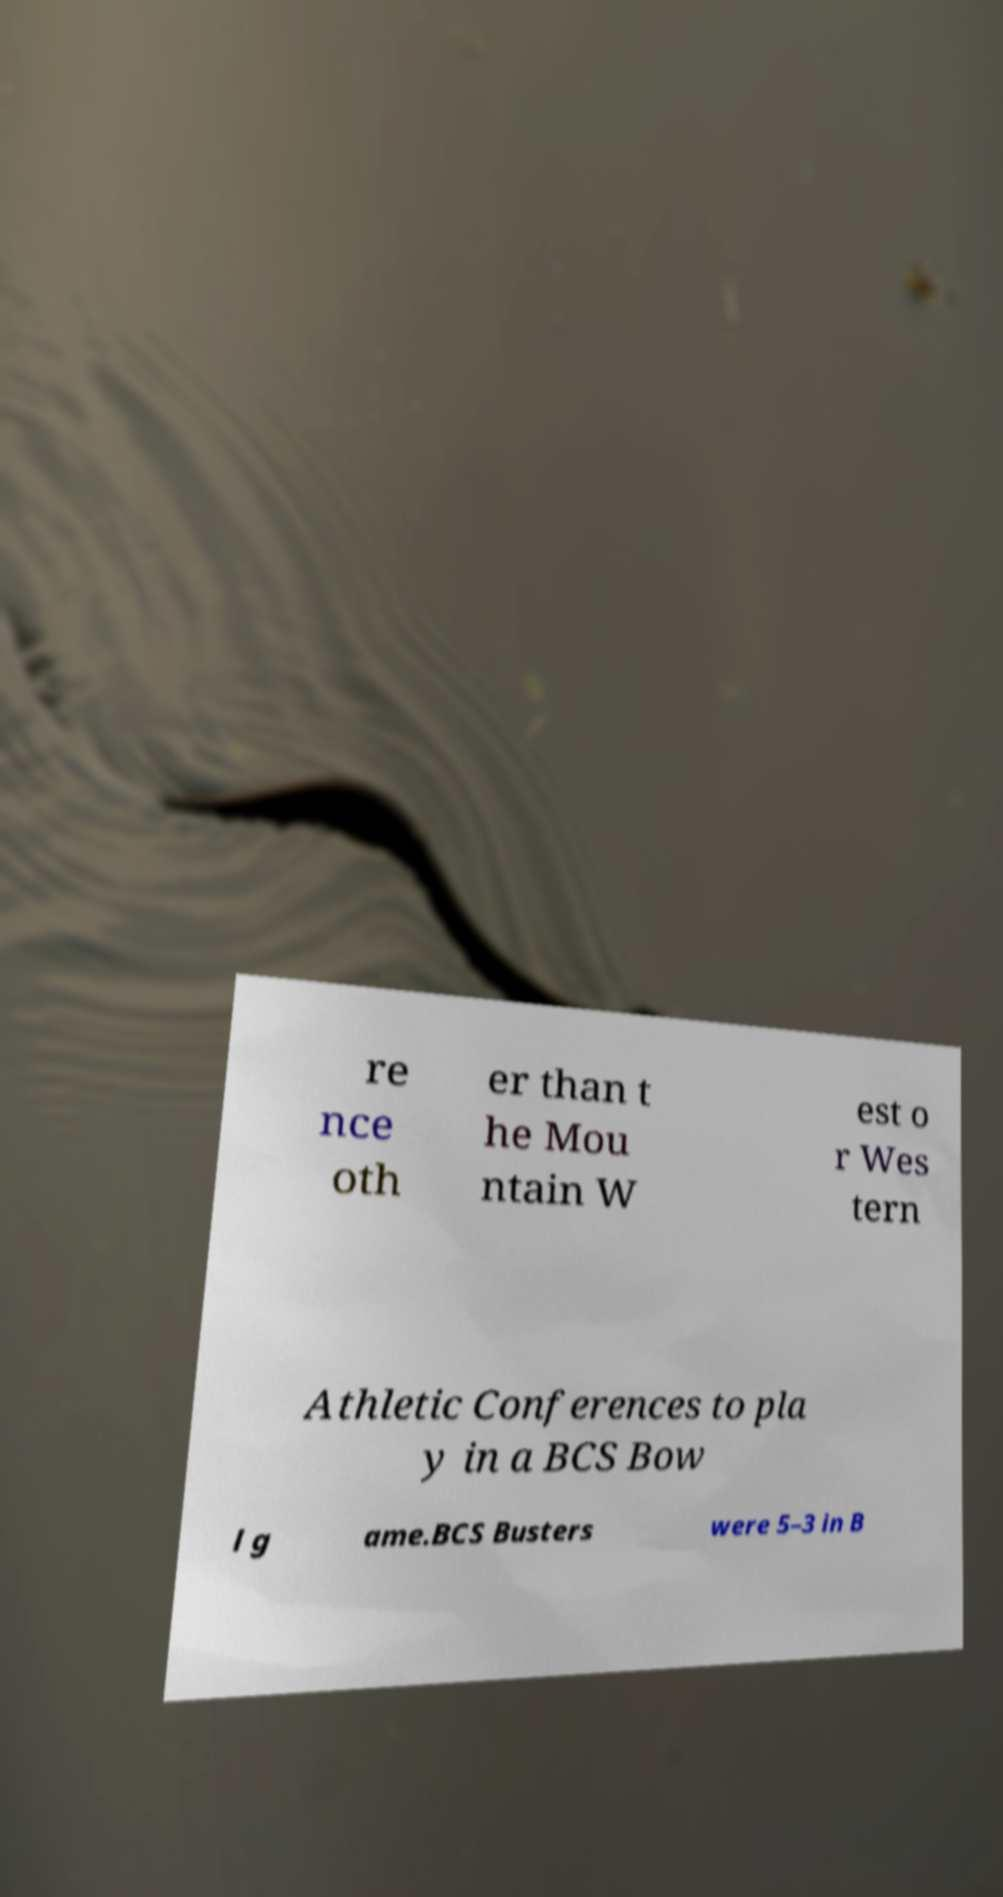There's text embedded in this image that I need extracted. Can you transcribe it verbatim? re nce oth er than t he Mou ntain W est o r Wes tern Athletic Conferences to pla y in a BCS Bow l g ame.BCS Busters were 5–3 in B 